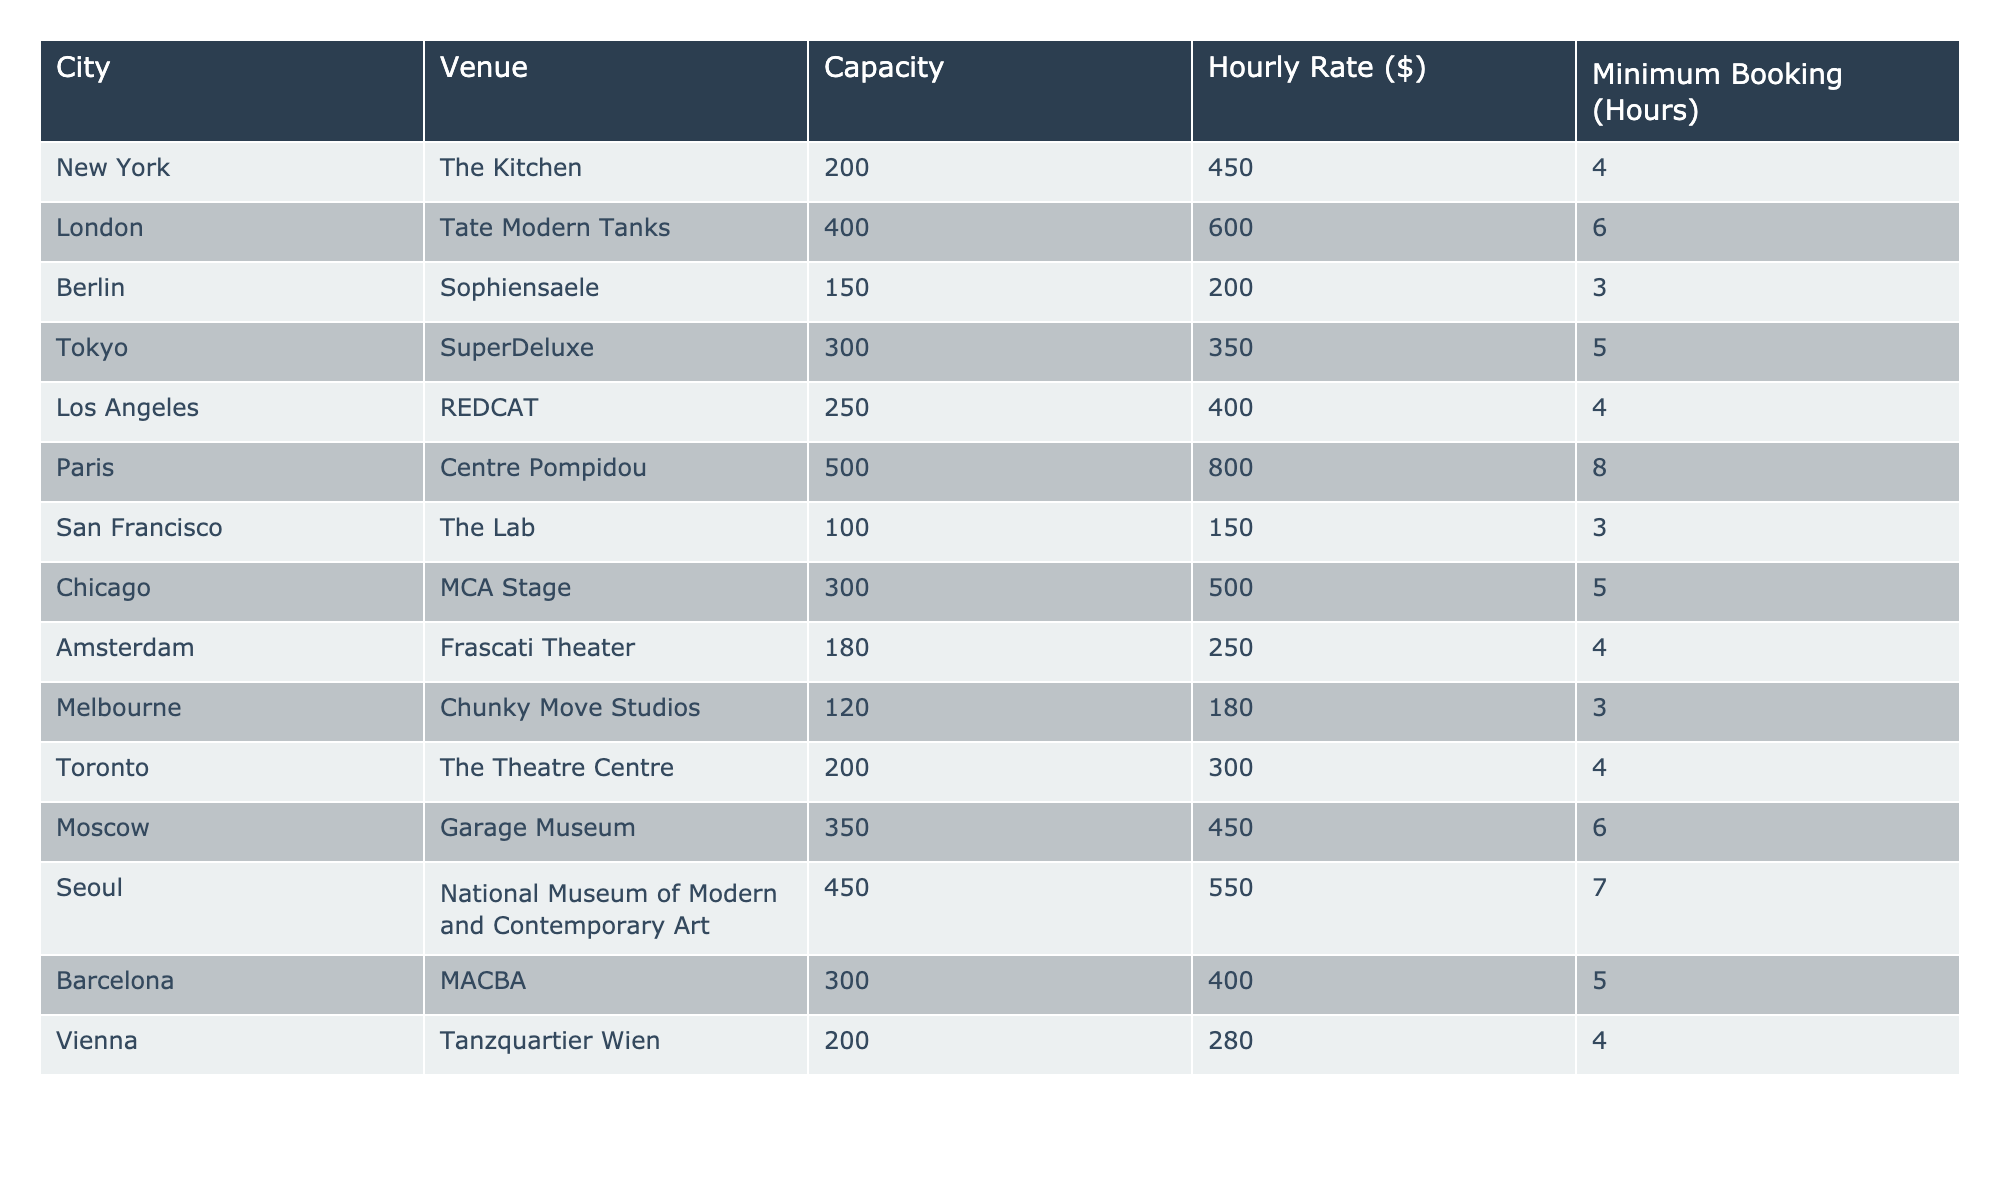What is the hourly rate for renting the Centre Pompidou in Paris? The table indicates the hourly rate for the Centre Pompidou, which is presented in the column labeled "Hourly Rate ($)." Looking directly at that entry, the hourly rate is 800.
Answer: 800 Which city has the highest minimum booking hours? The "Minimum Booking (Hours)" column lists the minimum required hours for each venue. By examining this column, we can see that the Centre Pompidou has the highest minimum booking requirement at 8 hours.
Answer: 8 What is the total capacity of venues in Berlin and Barcelona combined? First, we will identify the capacities of the venues in Berlin (Sophiensaele, capacity 150) and Barcelona (MACBA, capacity 300) from the "Capacity" column. We then add these two values: 150 + 300 = 450.
Answer: 450 Is the hourly rate for renting a venue in Tokyo higher than that in Los Angeles? The hourly rates from the "Hourly Rate ($)" column show that SuperDeluxe in Tokyo charges 350, while REDCAT in Los Angeles charges 400. Since 350 is less than 400, the answer is no.
Answer: No What is the average hourly rate of all venues listed in the table? To find the average hourly rate, we add all the hourly rates: 450 + 600 + 200 + 350 + 400 + 800 + 150 + 500 + 250 + 180 + 300 + 450 + 550 + 400 + 280 = 6,370. There are 15 venues in total, so we divide 6,370 by 15, which gives approximately 424.67.
Answer: 424.67 How many venues have a capacity greater than 300? By analyzing the "Capacity" column, we find that venues with a capacity above 300 are: Tate Modern Tanks (400), SuperDeluxe (300), and Garage Museum (350) and National Museum of Modern and Contemporary Art (450). Counting these, we find there are 4 venues.
Answer: 4 Is there a venue in San Francisco with a capacity less than 200? Looking at the "Capacity" column, The Lab in San Francisco has a capacity of 100, which is indeed less than 200. Therefore, the answer is yes.
Answer: Yes Which city has the venue with the lowest hourly rate? The table shows hourly rates for each venue, and the lowest rate is 150 for The Lab in San Francisco. Since San Francisco is associated with that venue, the answer is San Francisco.
Answer: San Francisco 